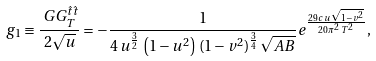Convert formula to latex. <formula><loc_0><loc_0><loc_500><loc_500>g _ { 1 } & \equiv \frac { \ G G _ { T } ^ { \hat { t } \hat { t } } } { 2 \sqrt { u } } = - \frac { 1 } { 4 \, u ^ { \frac { 3 } { 2 } } \, \left ( 1 - u ^ { 2 } \right ) \, ( 1 - v ^ { 2 } ) ^ { \frac { 3 } { 4 } } \, \sqrt { A B } } e ^ { \frac { 2 9 \, c \, u \, { \sqrt { 1 - v ^ { 2 } } } } { 2 0 \, { \pi } ^ { 2 } \, T ^ { 2 } } } ,</formula> 